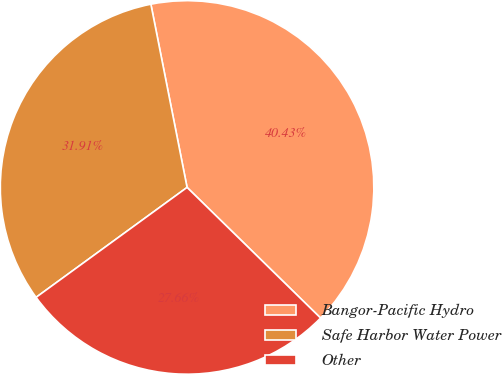<chart> <loc_0><loc_0><loc_500><loc_500><pie_chart><fcel>Bangor-Pacific Hydro<fcel>Safe Harbor Water Power<fcel>Other<nl><fcel>40.43%<fcel>31.91%<fcel>27.66%<nl></chart> 